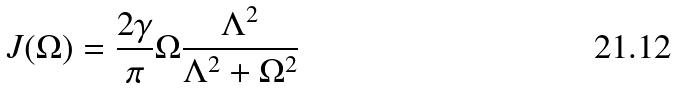<formula> <loc_0><loc_0><loc_500><loc_500>J ( \Omega ) = \frac { 2 \gamma } { \pi } \Omega \frac { \Lambda ^ { 2 } } { \Lambda ^ { 2 } + \Omega ^ { 2 } }</formula> 